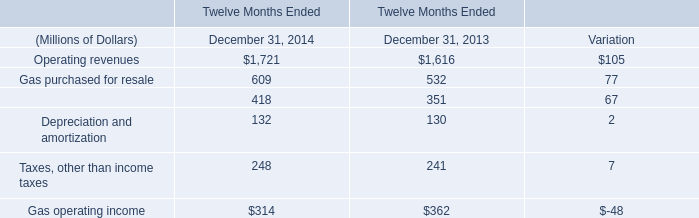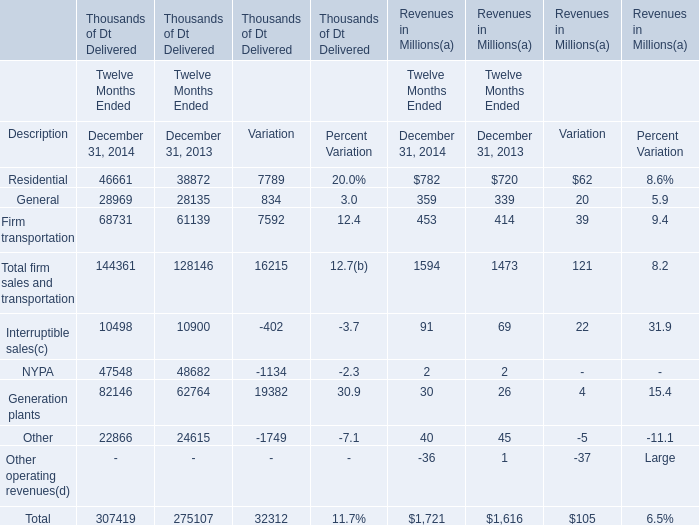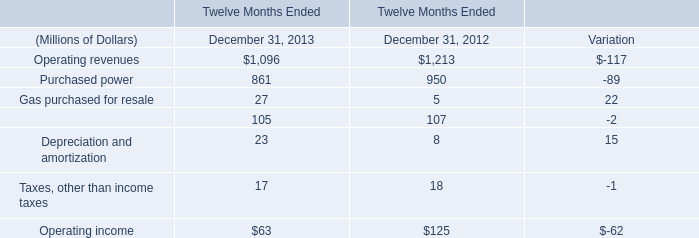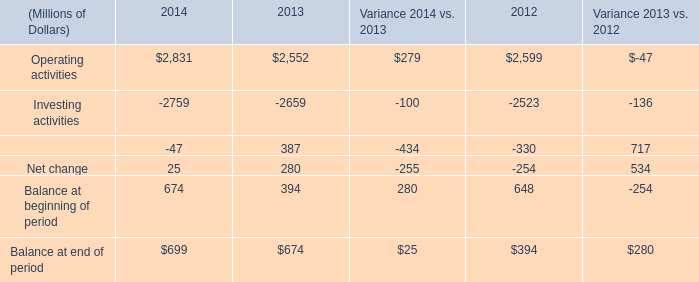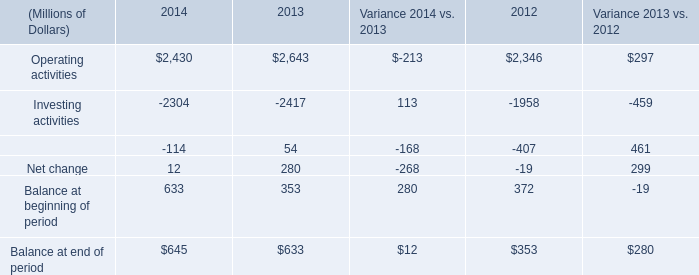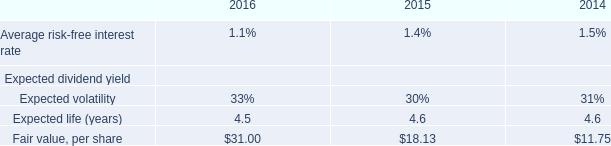What was the average of Residential for December 31, 2014, December 31, 2013, and Variation? (in thousand) 
Computations: (((46661 + 38872) + 7789) / 3)
Answer: 31107.33333. 